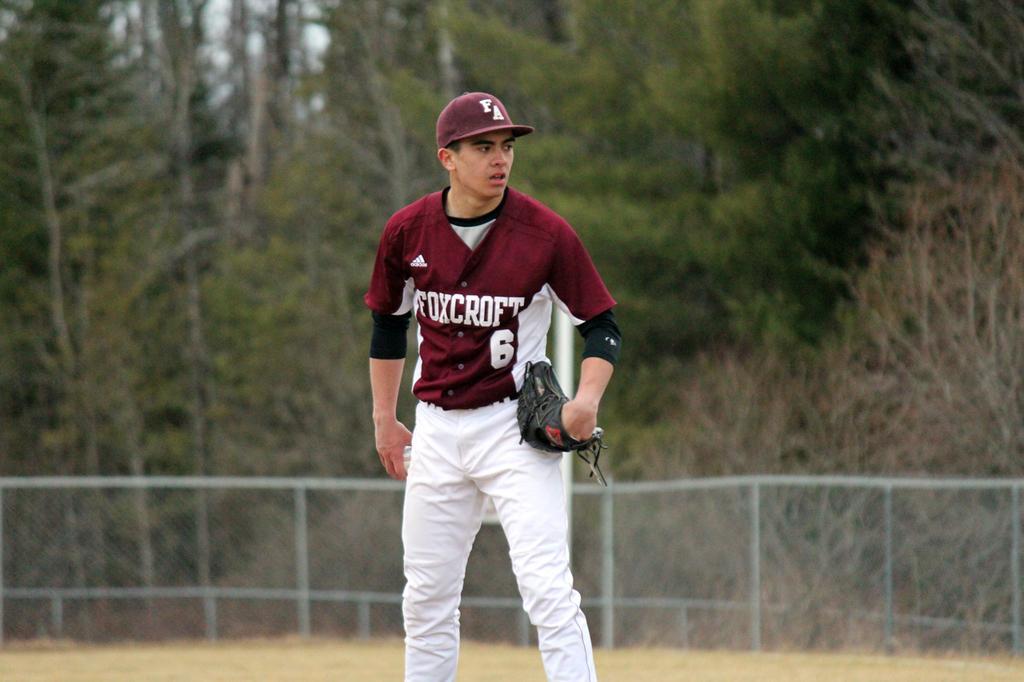Can you describe this image briefly? In this image I can see a person wearing maroon and white colored dress is standing and I can see he is wearing a black colored glove. In the background I can see the railing, few trees and the sky. 